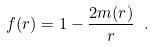<formula> <loc_0><loc_0><loc_500><loc_500>f ( r ) = 1 - \frac { 2 m ( r ) } { r } \ .</formula> 